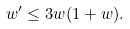<formula> <loc_0><loc_0><loc_500><loc_500>w ^ { \prime } \leq 3 w ( 1 + w ) .</formula> 